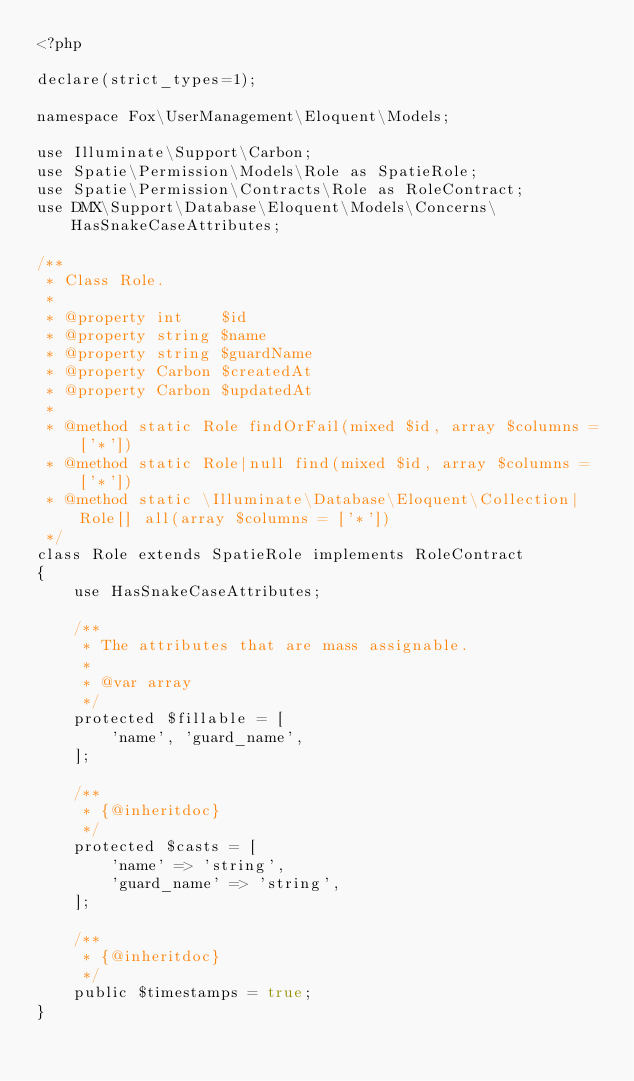<code> <loc_0><loc_0><loc_500><loc_500><_PHP_><?php

declare(strict_types=1);

namespace Fox\UserManagement\Eloquent\Models;

use Illuminate\Support\Carbon;
use Spatie\Permission\Models\Role as SpatieRole;
use Spatie\Permission\Contracts\Role as RoleContract;
use DMX\Support\Database\Eloquent\Models\Concerns\HasSnakeCaseAttributes;

/**
 * Class Role.
 *
 * @property int    $id
 * @property string $name
 * @property string $guardName
 * @property Carbon $createdAt
 * @property Carbon $updatedAt
 *
 * @method static Role findOrFail(mixed $id, array $columns = ['*'])
 * @method static Role|null find(mixed $id, array $columns = ['*'])
 * @method static \Illuminate\Database\Eloquent\Collection|Role[] all(array $columns = ['*'])
 */
class Role extends SpatieRole implements RoleContract
{
    use HasSnakeCaseAttributes;

    /**
     * The attributes that are mass assignable.
     *
     * @var array
     */
    protected $fillable = [
        'name', 'guard_name',
    ];

    /**
     * {@inheritdoc}
     */
    protected $casts = [
        'name' => 'string',
        'guard_name' => 'string',
    ];

    /**
     * {@inheritdoc}
     */
    public $timestamps = true;
}
</code> 